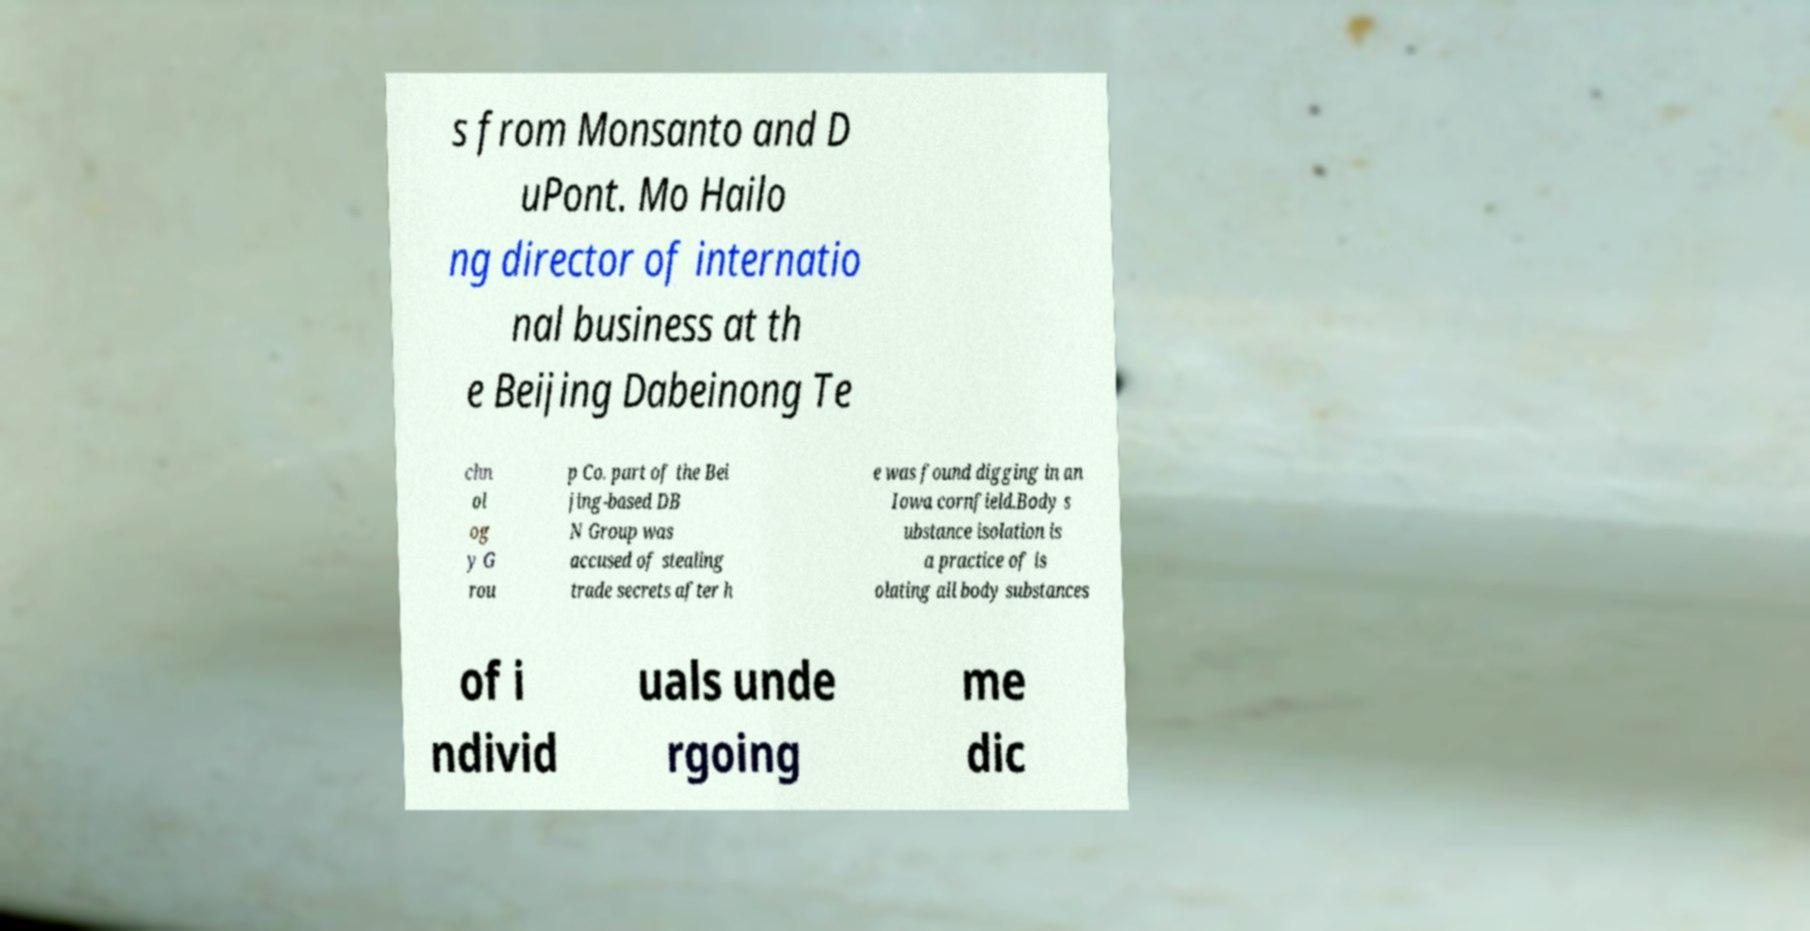Please read and relay the text visible in this image. What does it say? s from Monsanto and D uPont. Mo Hailo ng director of internatio nal business at th e Beijing Dabeinong Te chn ol og y G rou p Co. part of the Bei jing-based DB N Group was accused of stealing trade secrets after h e was found digging in an Iowa cornfield.Body s ubstance isolation is a practice of is olating all body substances of i ndivid uals unde rgoing me dic 